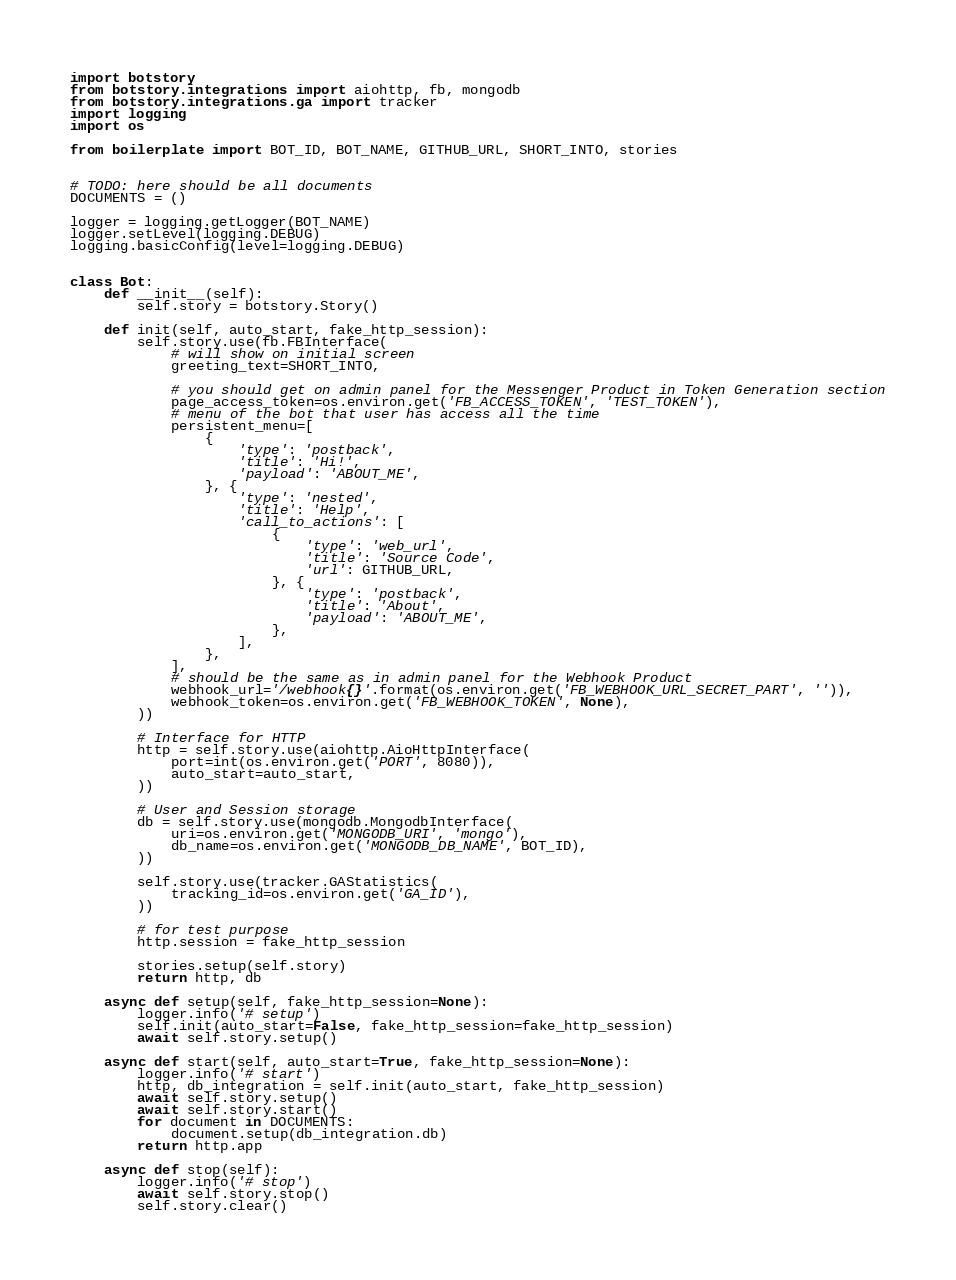<code> <loc_0><loc_0><loc_500><loc_500><_Python_>import botstory
from botstory.integrations import aiohttp, fb, mongodb
from botstory.integrations.ga import tracker
import logging
import os

from boilerplate import BOT_ID, BOT_NAME, GITHUB_URL, SHORT_INTO, stories


# TODO: here should be all documents
DOCUMENTS = ()

logger = logging.getLogger(BOT_NAME)
logger.setLevel(logging.DEBUG)
logging.basicConfig(level=logging.DEBUG)


class Bot:
    def __init__(self):
        self.story = botstory.Story()

    def init(self, auto_start, fake_http_session):
        self.story.use(fb.FBInterface(
            # will show on initial screen
            greeting_text=SHORT_INTO,

            # you should get on admin panel for the Messenger Product in Token Generation section
            page_access_token=os.environ.get('FB_ACCESS_TOKEN', 'TEST_TOKEN'),
            # menu of the bot that user has access all the time
            persistent_menu=[
                {
                    'type': 'postback',
                    'title': 'Hi!',
                    'payload': 'ABOUT_ME',
                }, {
                    'type': 'nested',
                    'title': 'Help',
                    'call_to_actions': [
                        {
                            'type': 'web_url',
                            'title': 'Source Code',
                            'url': GITHUB_URL,
                        }, {
                            'type': 'postback',
                            'title': 'About',
                            'payload': 'ABOUT_ME',
                        },
                    ],
                },
            ],
            # should be the same as in admin panel for the Webhook Product
            webhook_url='/webhook{}'.format(os.environ.get('FB_WEBHOOK_URL_SECRET_PART', '')),
            webhook_token=os.environ.get('FB_WEBHOOK_TOKEN', None),
        ))

        # Interface for HTTP
        http = self.story.use(aiohttp.AioHttpInterface(
            port=int(os.environ.get('PORT', 8080)),
            auto_start=auto_start,
        ))

        # User and Session storage
        db = self.story.use(mongodb.MongodbInterface(
            uri=os.environ.get('MONGODB_URI', 'mongo'),
            db_name=os.environ.get('MONGODB_DB_NAME', BOT_ID),
        ))

        self.story.use(tracker.GAStatistics(
            tracking_id=os.environ.get('GA_ID'),
        ))

        # for test purpose
        http.session = fake_http_session

        stories.setup(self.story)
        return http, db

    async def setup(self, fake_http_session=None):
        logger.info('# setup')
        self.init(auto_start=False, fake_http_session=fake_http_session)
        await self.story.setup()

    async def start(self, auto_start=True, fake_http_session=None):
        logger.info('# start')
        http, db_integration = self.init(auto_start, fake_http_session)
        await self.story.setup()
        await self.story.start()
        for document in DOCUMENTS:
            document.setup(db_integration.db)
        return http.app

    async def stop(self):
        logger.info('# stop')
        await self.story.stop()
        self.story.clear()
</code> 